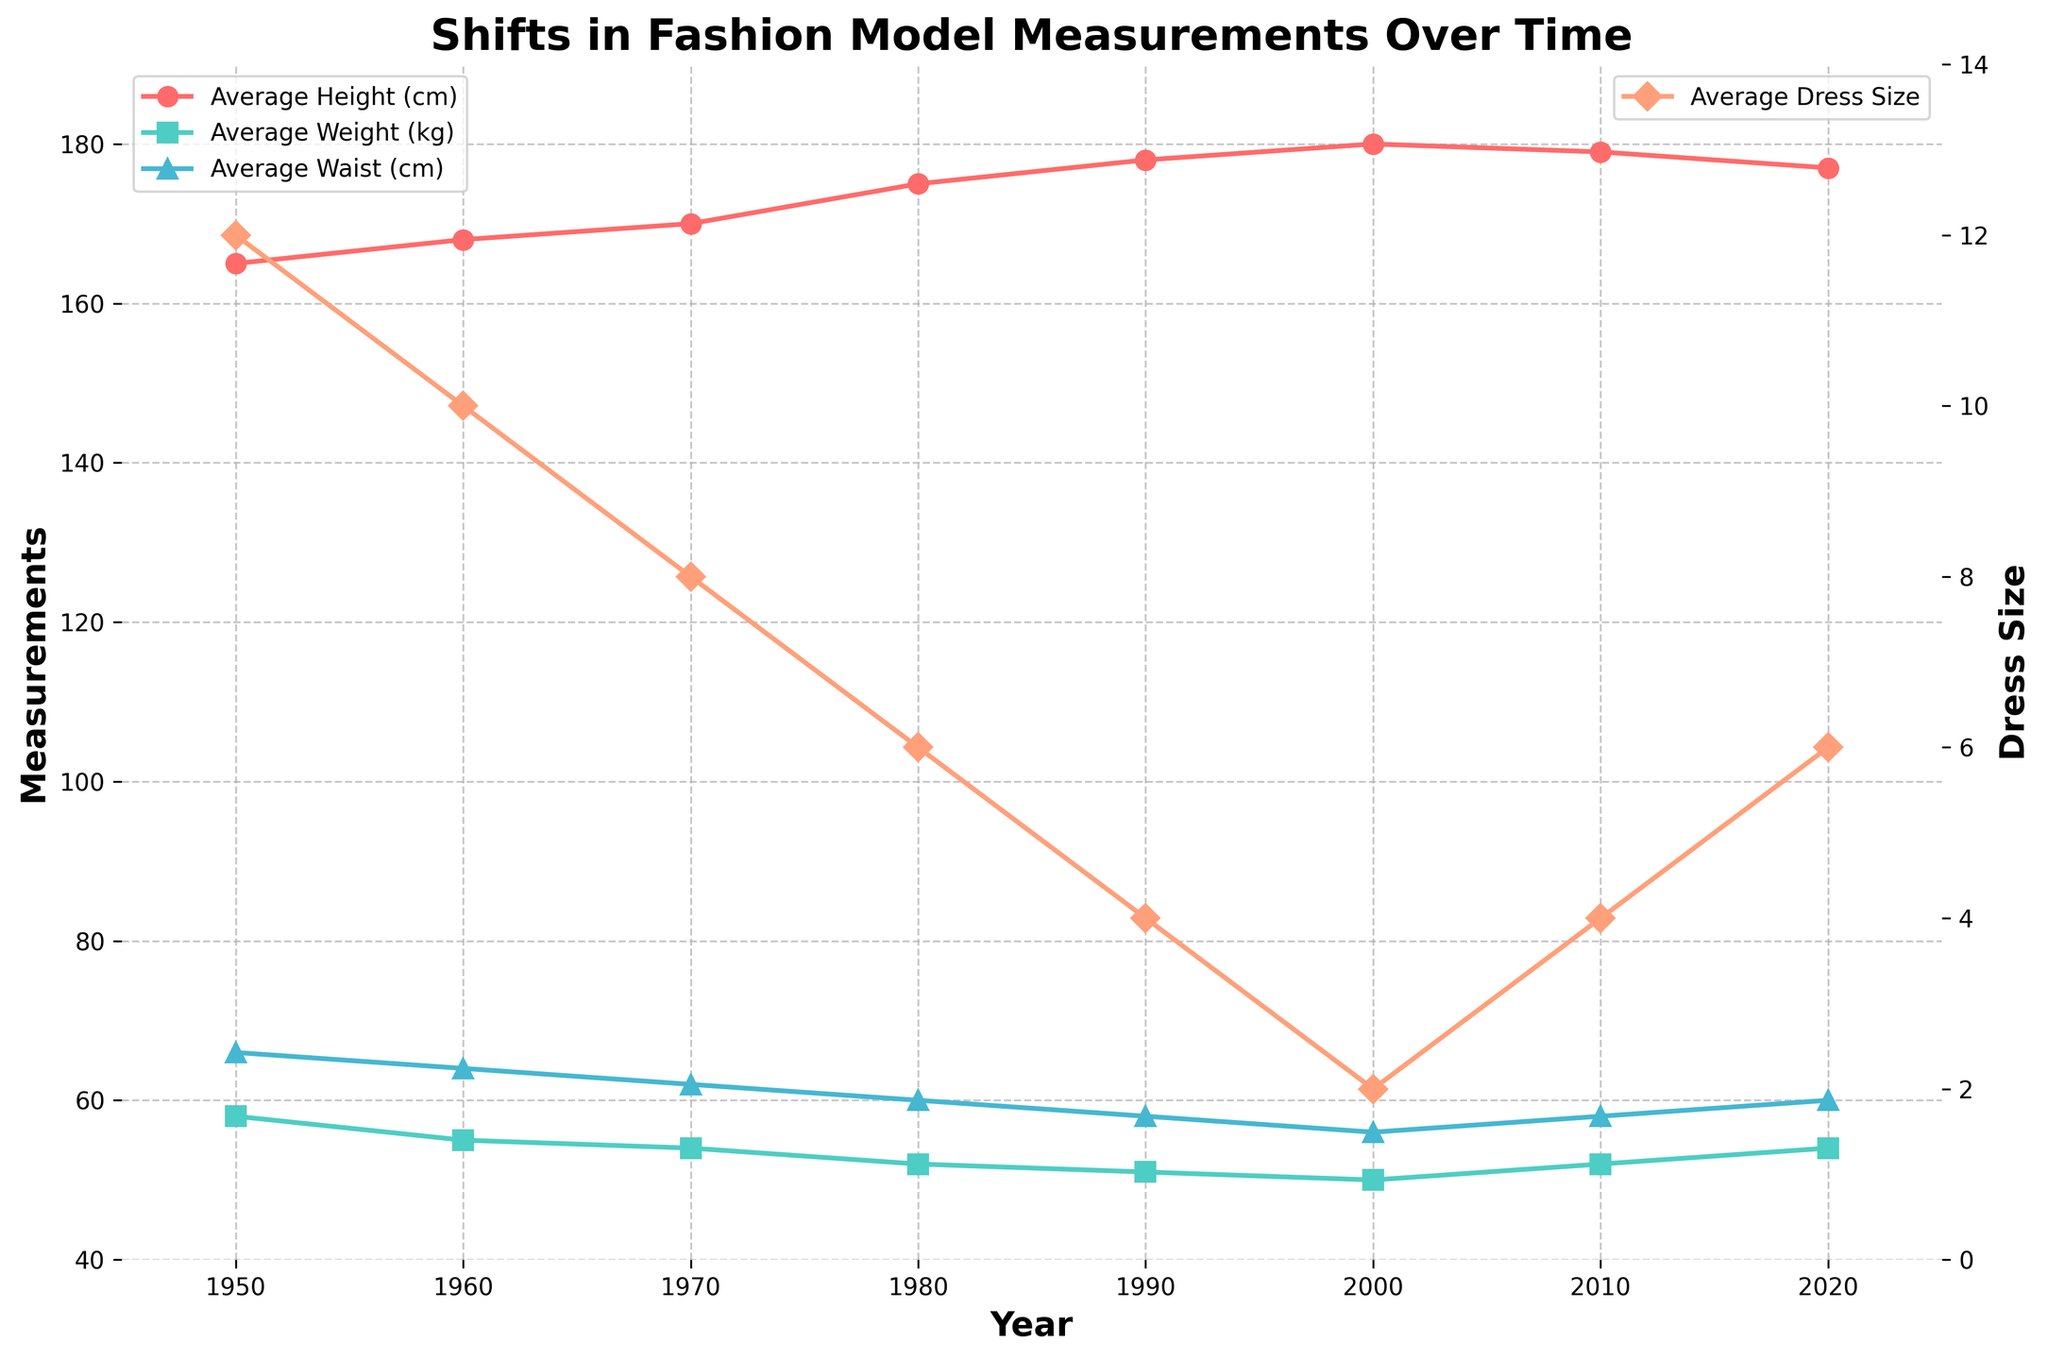What trends can you observe in the average height of fashion models over time? From 1950 to 2000, the average height of fashion models increased steadily from 165 cm to 180 cm. However, after 2000, there was a slight decrease to 179 cm in 2010 and 177 cm in 2020.
Answer: Steady increase, then slight decrease How did the average weight of fashion models change from 1950 to 2020? The average weight of fashion models decreased from 58 kg in 1950 to 50 kg in 2000, and then increased slightly to 54 kg in 2020.
Answer: Decreased, then slightly increased Compare the average waist measurements in the 1950s and the 2020s. In the 1950s, the average waist measurement was 66 cm, while in the 2020s, it was 60 cm. This indicates a decline of 6 cm.
Answer: 66 cm in 1950, 60 cm in 2020 What can be inferred about the trends in dress sizes of fashion models over the decades? Dress sizes decreased significantly from 12 in 1950 to 2 in 2000 and then increased to 6 by 2020.
Answer: Decreased, then increased Which decade saw the most significant change in measurements? The decade between 1970 and 1980 saw the most significant change: average height increased by 5 cm, average weight decreased by 2 kg, waist size decreased by 2 cm, and dress size dropped by 2 sizes.
Answer: 1970 to 1980 What is the relationship between average weight and average waist measurements over time? As average weight decreased from 58 kg in 1950 to 50 kg in 2000, the average waist measurement also decreased from 66 cm to 56 cm. The pattern suggests a correlation where lower weight corresponded with a smaller waist, which reversed slightly after 2000.
Answer: Correlated decrease, slight reversal after 2000 Compare the dress sizes in the 1950s and the 1980s. In the 1950s, the average dress size was 12, whereas in the 1980s, it had decreased to 6.
Answer: 12 in the 1950s, 6 in the 1980s How does the average height in 2020 compare to 1980? The average height in 2020 was 177 cm, which is 2 cm less than the 179 cm average height in 1980.
Answer: 2 cm less Between which successive years was the highest increase in average height observed? The highest increase in average height was observed between 1970 and 1980, where it increased by 5 cm (from 170 cm to 175 cm).
Answer: 1970 to 1980 Calculate the average dress size over the entire period. The average dress sizes for the years are 12, 10, 8, 6, 4, 2, 4, and 6. Summing these values: (12 + 10 + 8 + 6 + 4 + 2 + 4 + 6) = 52. Dividing by the number of years (8), the average dress size is 52 / 8 = 6.5.
Answer: 6.5 